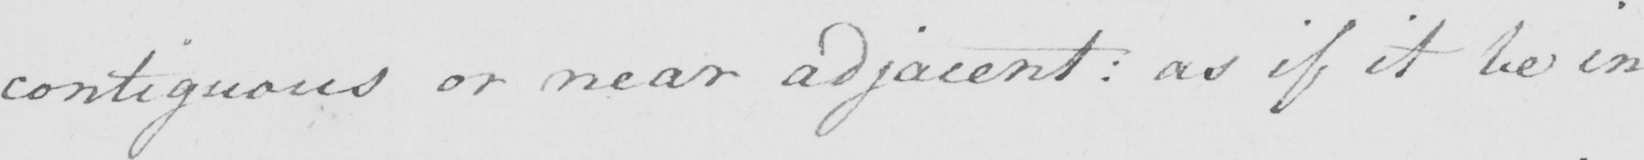Can you read and transcribe this handwriting? contiguous or near adjacent :  as if it be in 